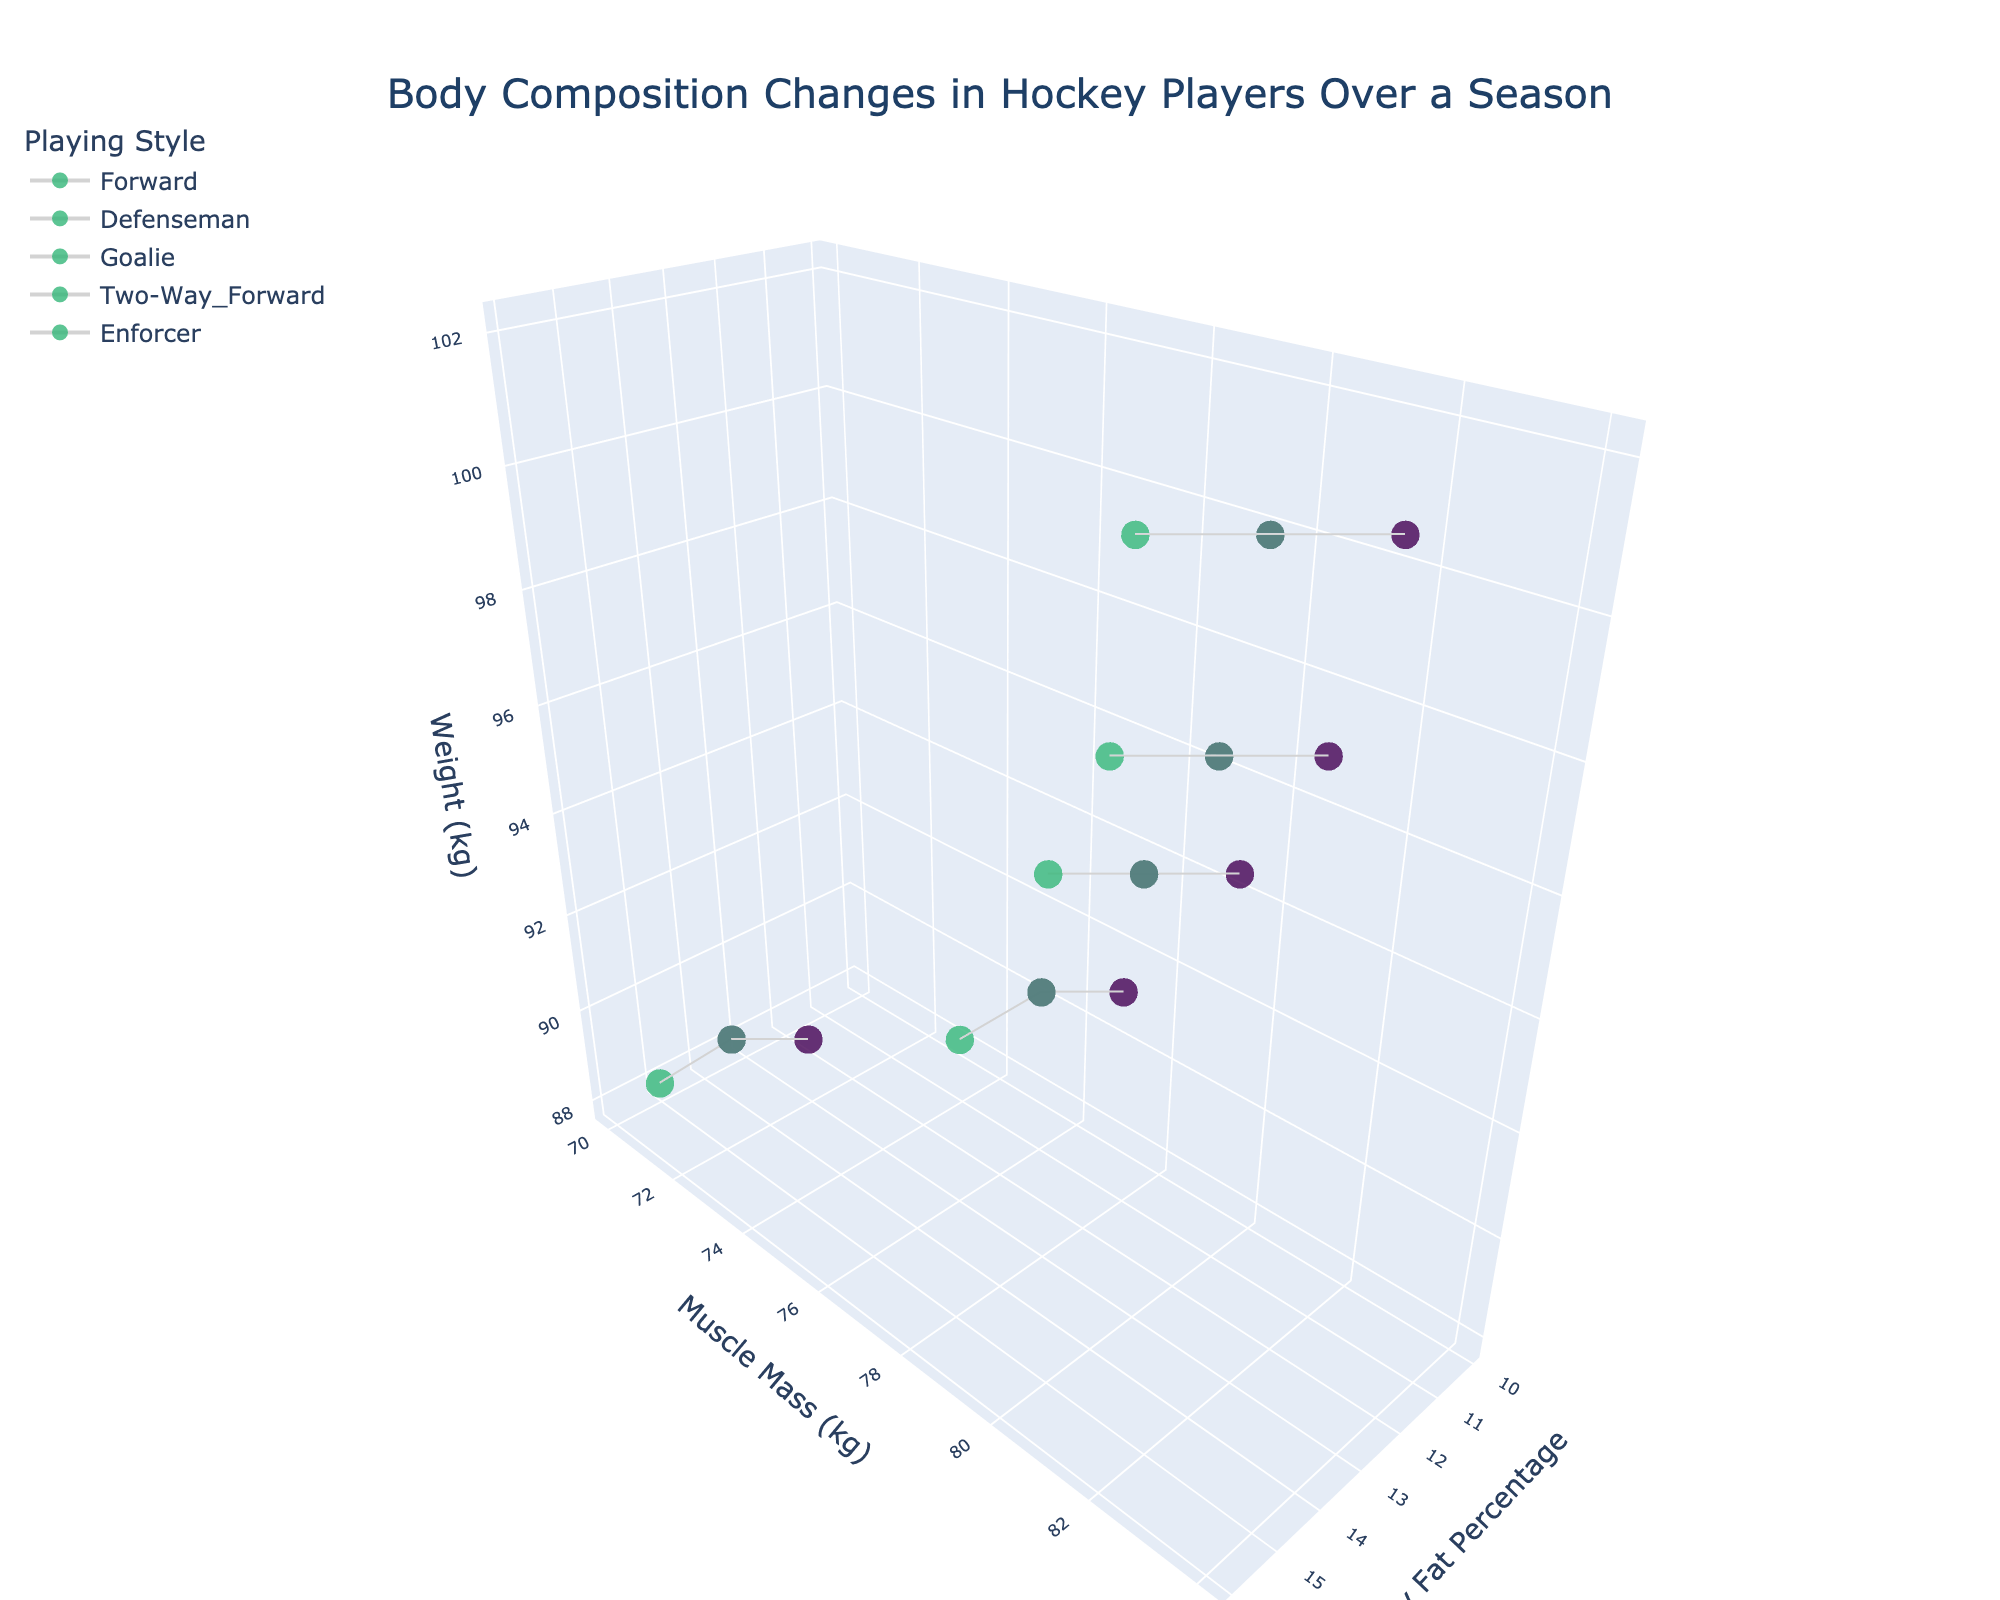What is the title of the plot? The plot title is located at the top center of the plot and is typically one of the first elements seen.
Answer: Body Composition Changes in Hockey Players Over a Season How many playing styles are represented in the plot? By counting the different markers or legend entries for each unique playing style, we can determine the total number of playing styles in the plot.
Answer: 5 Which playing style has the highest muscle mass (kg) in March? Locate the data points for March for each playing style, then identify and compare their muscle mass values. The Defenseman data point in March shows the highest muscle mass at 82 kg.
Answer: Defenseman What trend can be observed in the body fat percentage of Two-Way Forwards over the season? By tracking the data points of Two-Way Forwards over the months, we can observe the changes in their body fat percentage, which decreases from September to March and increases again in June.
Answer: Decrease then increase Are there any playing styles where the weight remains constant throughout the season? Reviewing the z-axis (Weight) values for each playing style over the months, Defenseman and Enforcers have constant weights throughout the season.
Answer: Defenseman, Enforcer Which month represents the lowest body fat percentage for Forwards? By looking at the x-axis (Body Fat Percentage) values for Forwards and identifying the lowest one, which occurs in March at 10%.
Answer: March How does the muscle mass of Goalies change from September to December? Checking the muscle mass values (y-axis) for Goalies in September and December reveals that it increases by 1 kg, from 70 kg to 71 kg.
Answer: Increases by 1 kg Which playing style experiences the largest decrease in body fat percentage from September to March? By calculating the difference in body fat percentage values between September and March for each playing style, Enforcer shows the largest decrease from 16% to 14%.
Answer: Enforcer What is the average weight of Forwards over the season? Adding the weight values (z-axis) for Forwards over all months and dividing by four, the average is (90 + 91 + 91 + 91) / 4 = 90.75 kg.
Answer: 90.75 kg Do Goalies have a consistent trend in muscle mass change across the season? Reviewing the muscle mass (y-axis) changes for Goalies month by month, a pattern of increasing muscle mass from September to March followed by a decrease to June can be observed.
Answer: Increase then decrease 